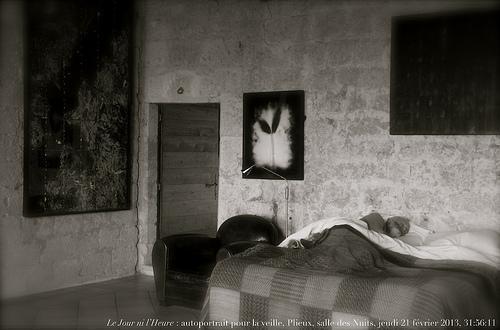How many pictures are on the walls?
Give a very brief answer. 3. How many people are in the room?
Give a very brief answer. 1. 